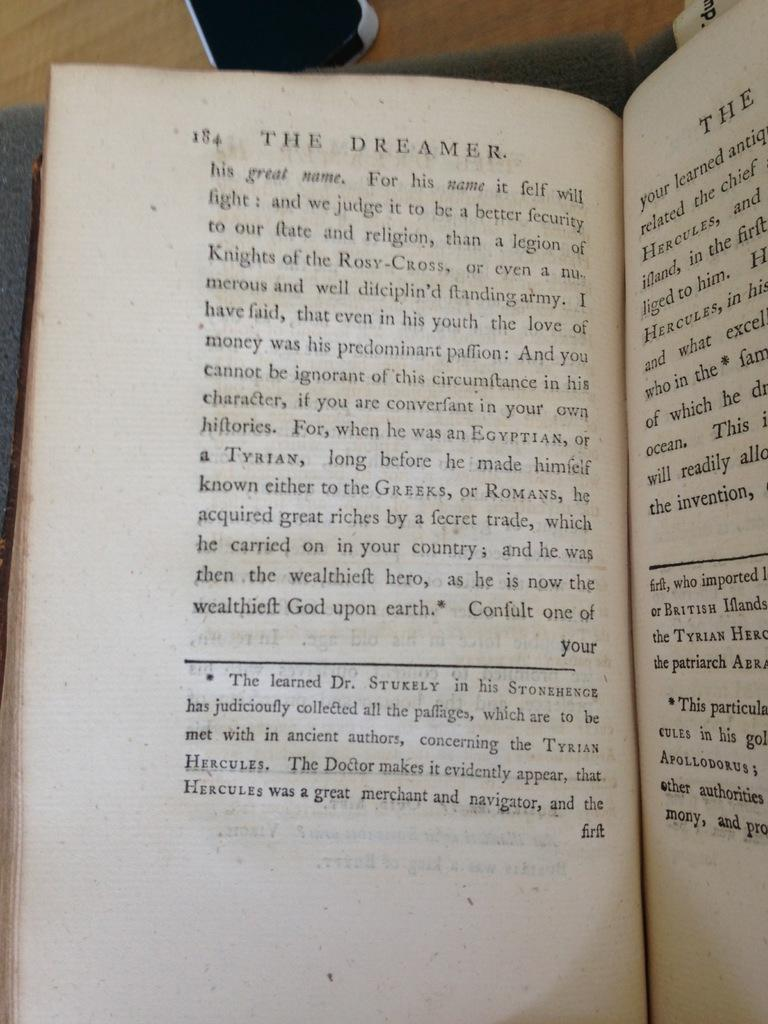Provide a one-sentence caption for the provided image. A book opened up to page 18 with the title, The Dreamer, at the top. 